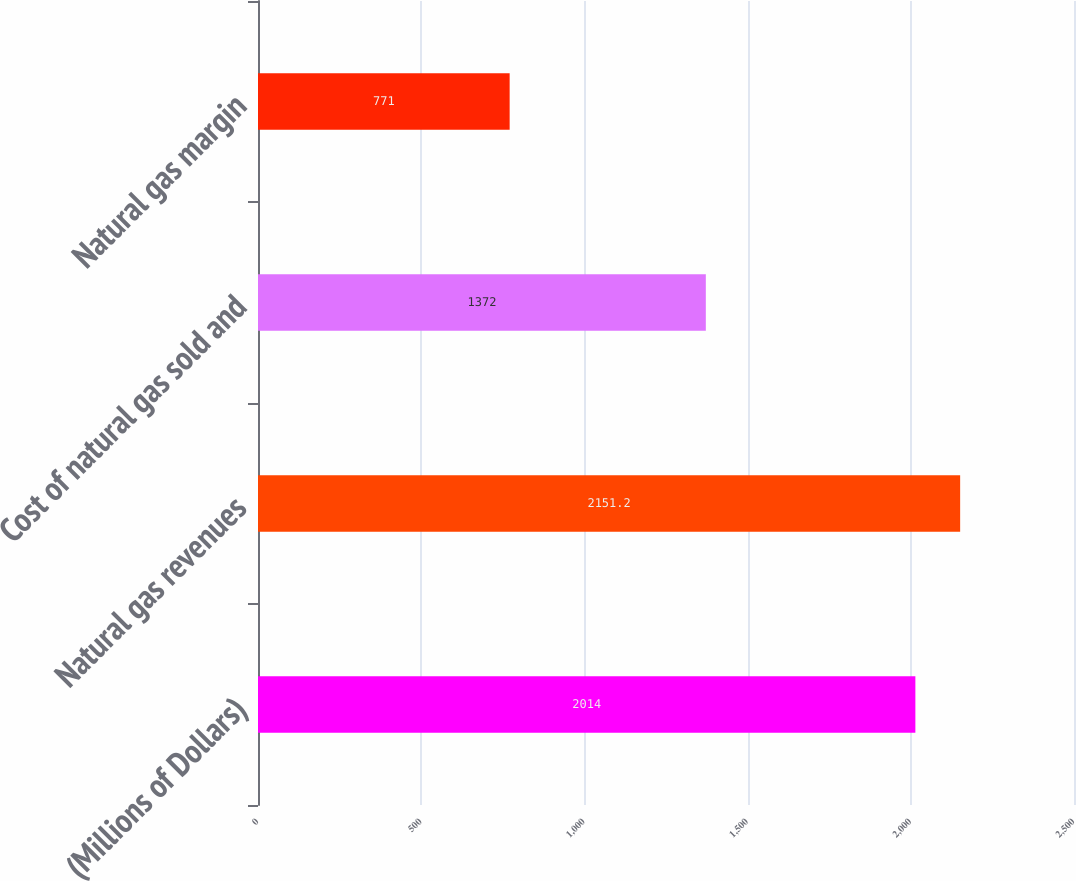Convert chart to OTSL. <chart><loc_0><loc_0><loc_500><loc_500><bar_chart><fcel>(Millions of Dollars)<fcel>Natural gas revenues<fcel>Cost of natural gas sold and<fcel>Natural gas margin<nl><fcel>2014<fcel>2151.2<fcel>1372<fcel>771<nl></chart> 